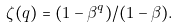<formula> <loc_0><loc_0><loc_500><loc_500>\zeta ( q ) = ( 1 - \beta ^ { q } ) / ( 1 - \beta ) .</formula> 